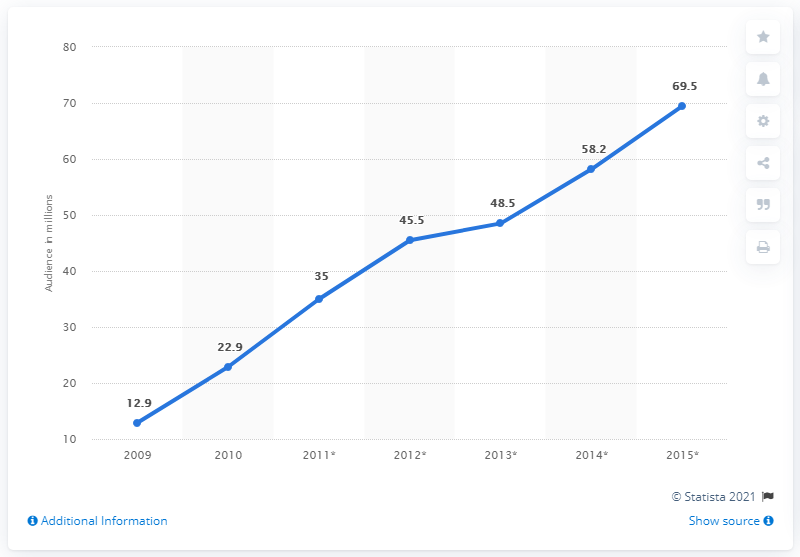Indicate a few pertinent items in this graphic. The audience for social gaming in Russia increased significantly from 2009 to 2015, with the largest growth occurring in 2015. In 2009, there were approximately 12.9 million users involved in social gaming in Russia. The audience and forecast for social gaming in Russia decreased significantly from 2009 to 2015. The estimated number of users of social gaming in Russia in 2015 was 69.5. 